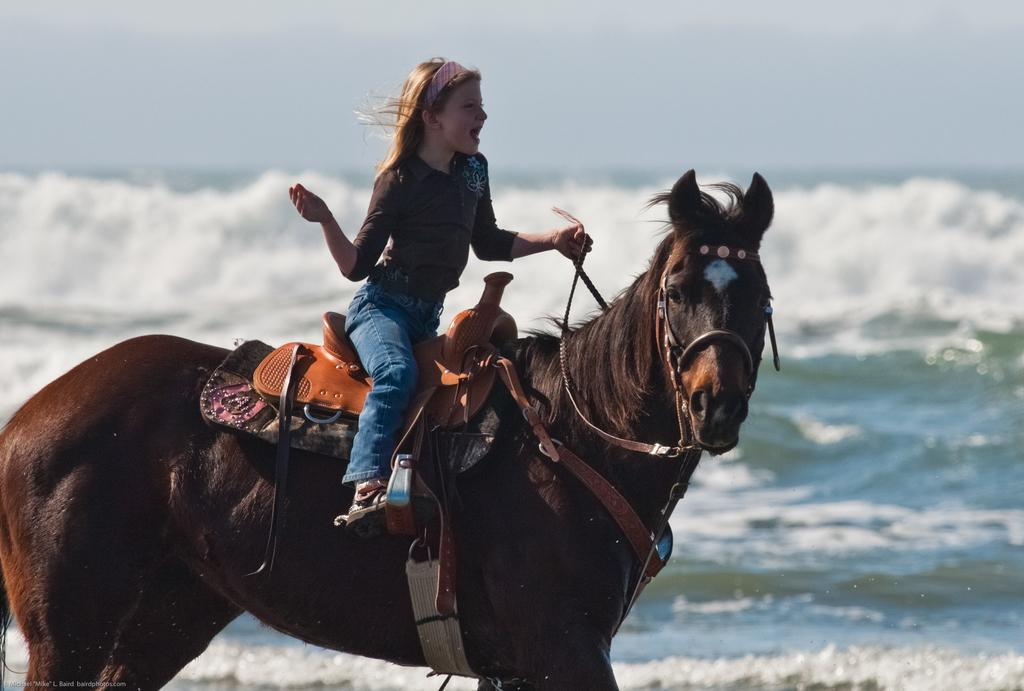Who is the main subject in the image? There is a girl in the image. What is the girl doing in the image? The girl is sitting on a horse. What can be seen in the background of the image? There is a sea and a sky visible in the background of the image. What type of quill is the girl using to teach in the image? There is no indication in the image that the girl is teaching or using a quill. 